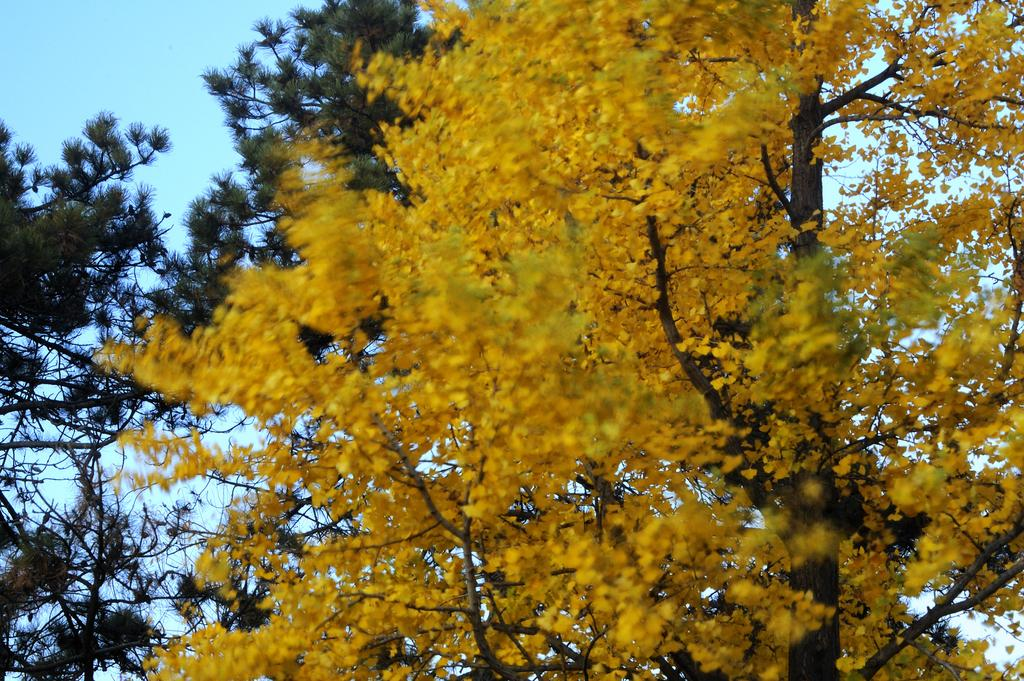What type of vegetation can be seen in the image? There are trees in the image. What color are the leaves on the trees? The leaves on the trees are yellow. What else is visible in the image besides the trees? The sky is visible in the image. How many babies are sitting on the sink in the image? There are no babies or sinks present in the image. 